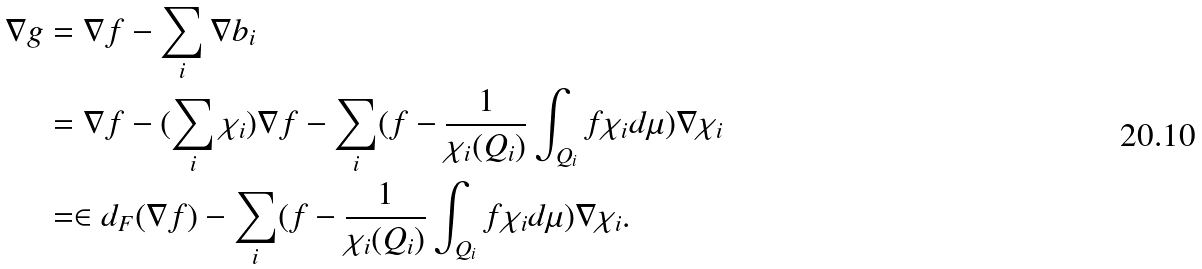Convert formula to latex. <formula><loc_0><loc_0><loc_500><loc_500>\nabla g & = \nabla f - \sum _ { i } \nabla b _ { i } \\ & = \nabla f - ( \sum _ { i } \chi _ { i } ) \nabla f - \sum _ { i } ( f - \frac { 1 } { \chi _ { i } ( Q _ { i } ) } \int _ { Q _ { i } } f \chi _ { i } d \mu ) \nabla \chi _ { i } \\ & = \in d _ { F } ( \nabla f ) - \sum _ { i } ( f - \frac { 1 } { \chi _ { i } ( Q _ { i } ) } \int _ { Q _ { i } } f \chi _ { i } d \mu ) \nabla \chi _ { i } .</formula> 